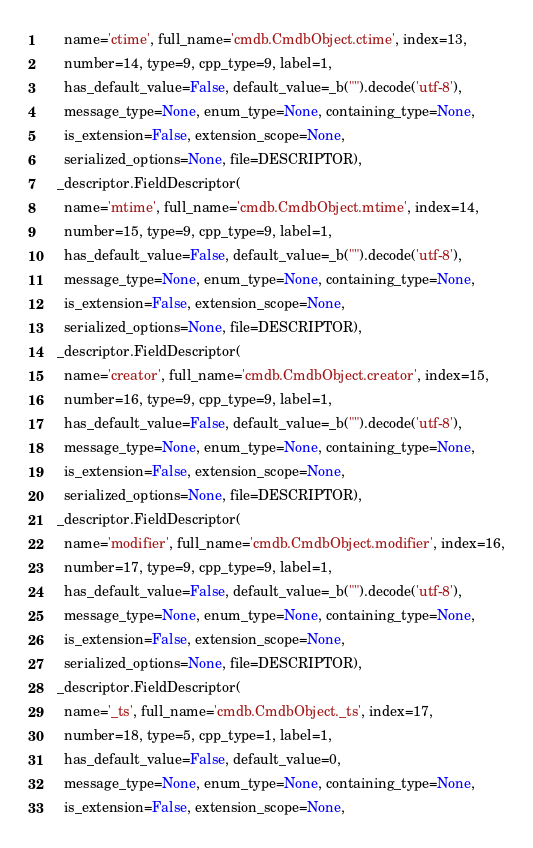<code> <loc_0><loc_0><loc_500><loc_500><_Python_>      name='ctime', full_name='cmdb.CmdbObject.ctime', index=13,
      number=14, type=9, cpp_type=9, label=1,
      has_default_value=False, default_value=_b("").decode('utf-8'),
      message_type=None, enum_type=None, containing_type=None,
      is_extension=False, extension_scope=None,
      serialized_options=None, file=DESCRIPTOR),
    _descriptor.FieldDescriptor(
      name='mtime', full_name='cmdb.CmdbObject.mtime', index=14,
      number=15, type=9, cpp_type=9, label=1,
      has_default_value=False, default_value=_b("").decode('utf-8'),
      message_type=None, enum_type=None, containing_type=None,
      is_extension=False, extension_scope=None,
      serialized_options=None, file=DESCRIPTOR),
    _descriptor.FieldDescriptor(
      name='creator', full_name='cmdb.CmdbObject.creator', index=15,
      number=16, type=9, cpp_type=9, label=1,
      has_default_value=False, default_value=_b("").decode('utf-8'),
      message_type=None, enum_type=None, containing_type=None,
      is_extension=False, extension_scope=None,
      serialized_options=None, file=DESCRIPTOR),
    _descriptor.FieldDescriptor(
      name='modifier', full_name='cmdb.CmdbObject.modifier', index=16,
      number=17, type=9, cpp_type=9, label=1,
      has_default_value=False, default_value=_b("").decode('utf-8'),
      message_type=None, enum_type=None, containing_type=None,
      is_extension=False, extension_scope=None,
      serialized_options=None, file=DESCRIPTOR),
    _descriptor.FieldDescriptor(
      name='_ts', full_name='cmdb.CmdbObject._ts', index=17,
      number=18, type=5, cpp_type=1, label=1,
      has_default_value=False, default_value=0,
      message_type=None, enum_type=None, containing_type=None,
      is_extension=False, extension_scope=None,</code> 